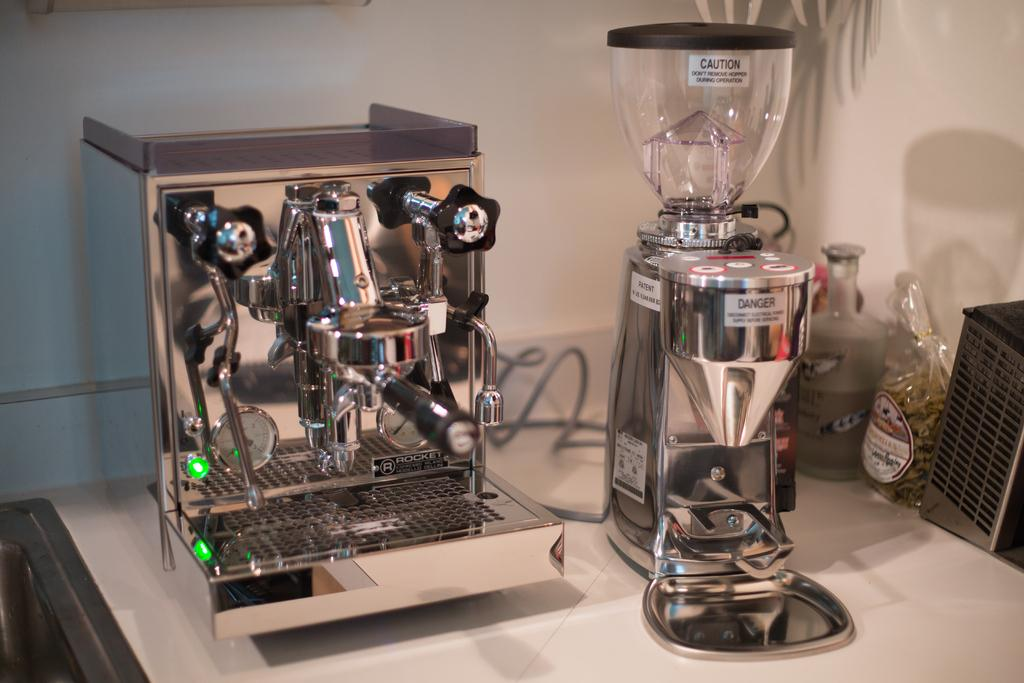<image>
Create a compact narrative representing the image presented. A piece of kitchen equipment has a danger sticker on it. 